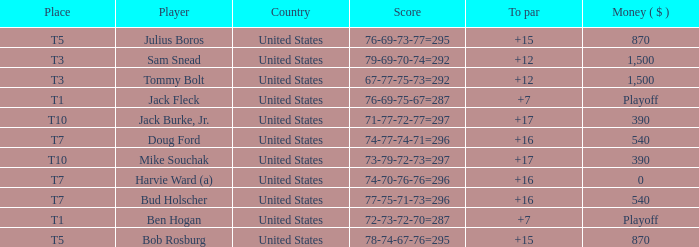What is the total of all to par with player Bob Rosburg? 15.0. 